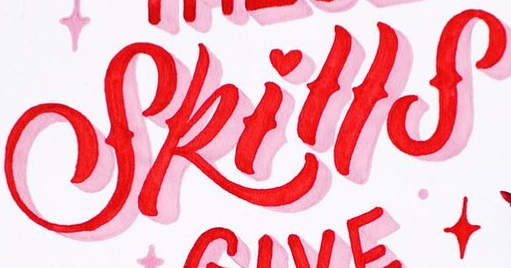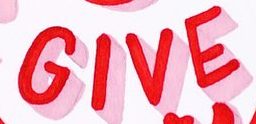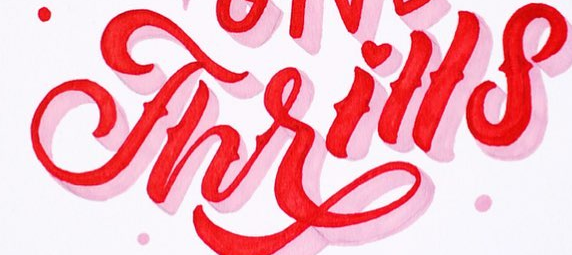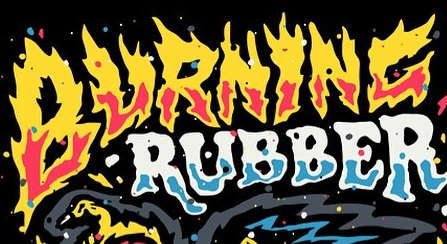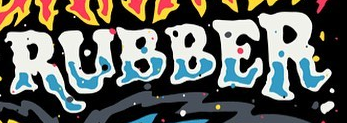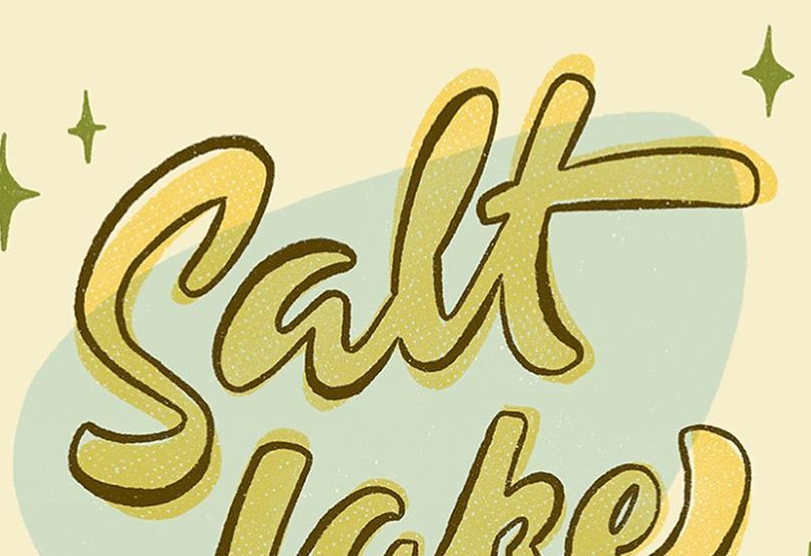What words can you see in these images in sequence, separated by a semicolon? Skills; GIVE; Thrills; BURNINC; RUBBER; Salt 